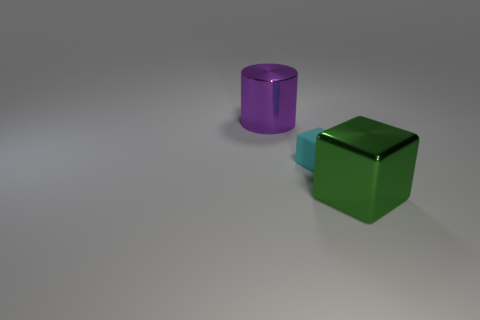Is there anything else that has the same shape as the big purple thing?
Provide a short and direct response. No. Are there any other things that have the same material as the purple object?
Your answer should be very brief. Yes. The metallic block has what color?
Make the answer very short. Green. Is the metal block the same color as the cylinder?
Offer a terse response. No. What number of big shiny objects are left of the large thing in front of the tiny cyan rubber cube?
Offer a very short reply. 1. There is a object that is both in front of the purple thing and behind the large green metal thing; what is its size?
Your answer should be very brief. Small. There is a thing in front of the tiny cyan matte thing; what is its material?
Provide a succinct answer. Metal. Are there any small brown things of the same shape as the big green shiny thing?
Provide a succinct answer. No. How many other big shiny objects are the same shape as the green metal object?
Ensure brevity in your answer.  0. Does the metallic thing in front of the big purple shiny cylinder have the same size as the metal object behind the tiny object?
Provide a short and direct response. Yes. 